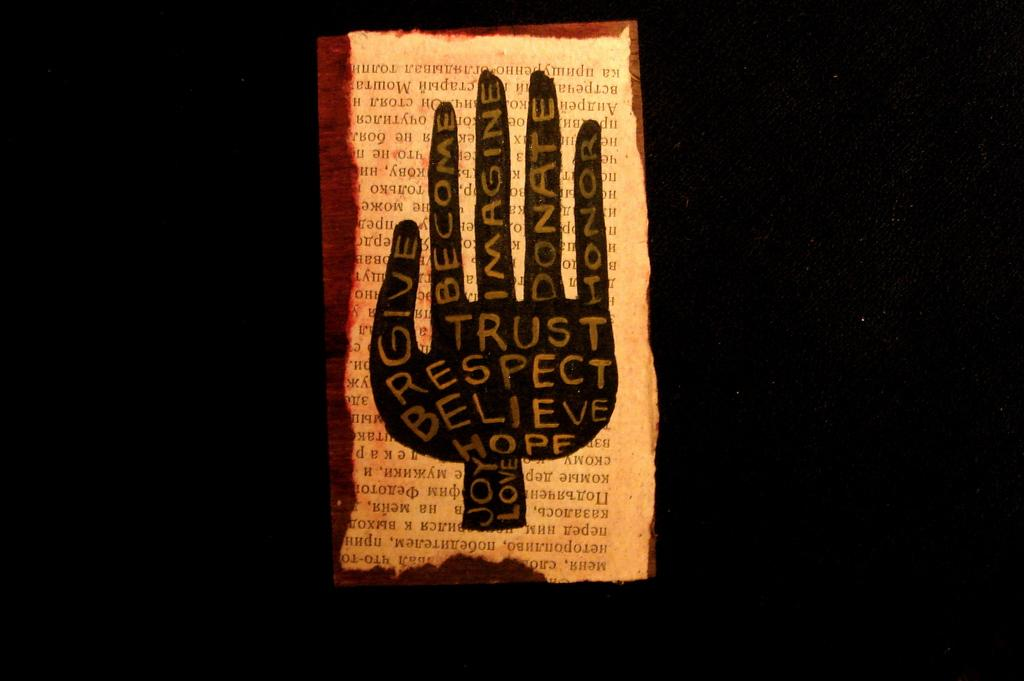Provide a one-sentence caption for the provided image. A page that has a hand with many positive words such as believe and hope. 